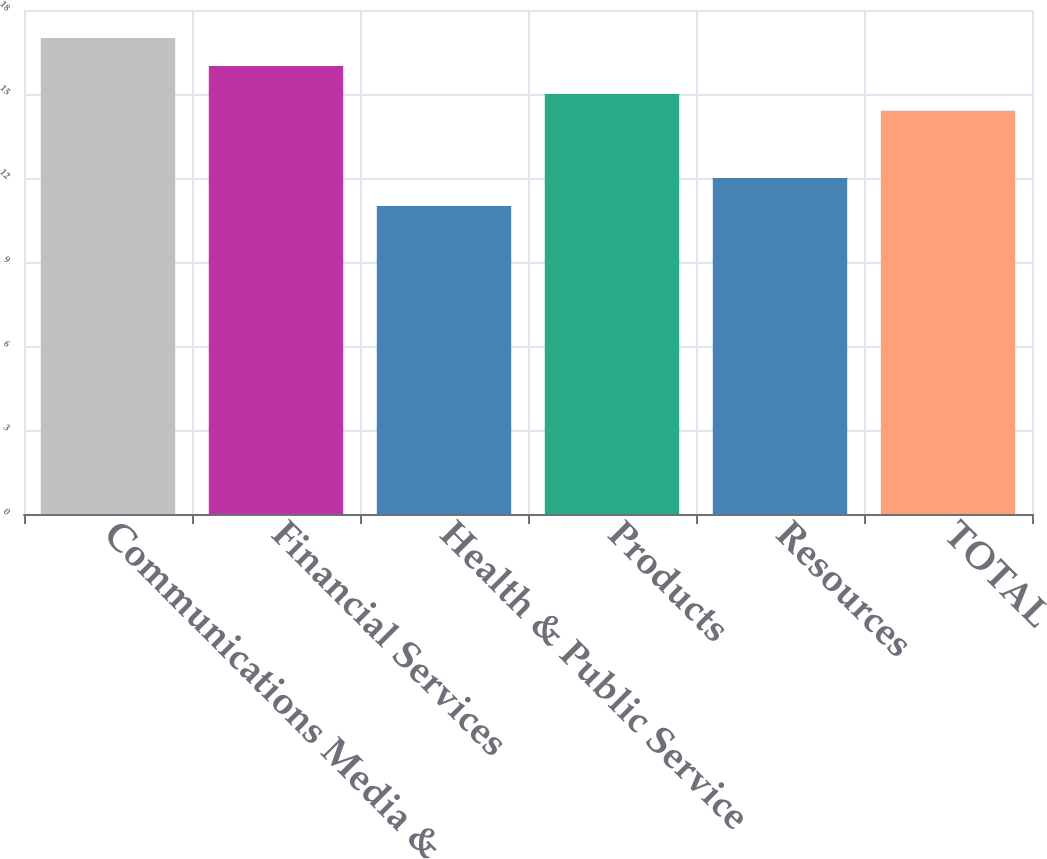Convert chart. <chart><loc_0><loc_0><loc_500><loc_500><bar_chart><fcel>Communications Media &<fcel>Financial Services<fcel>Health & Public Service<fcel>Products<fcel>Resources<fcel>TOTAL<nl><fcel>17<fcel>16<fcel>11<fcel>15<fcel>12<fcel>14.4<nl></chart> 